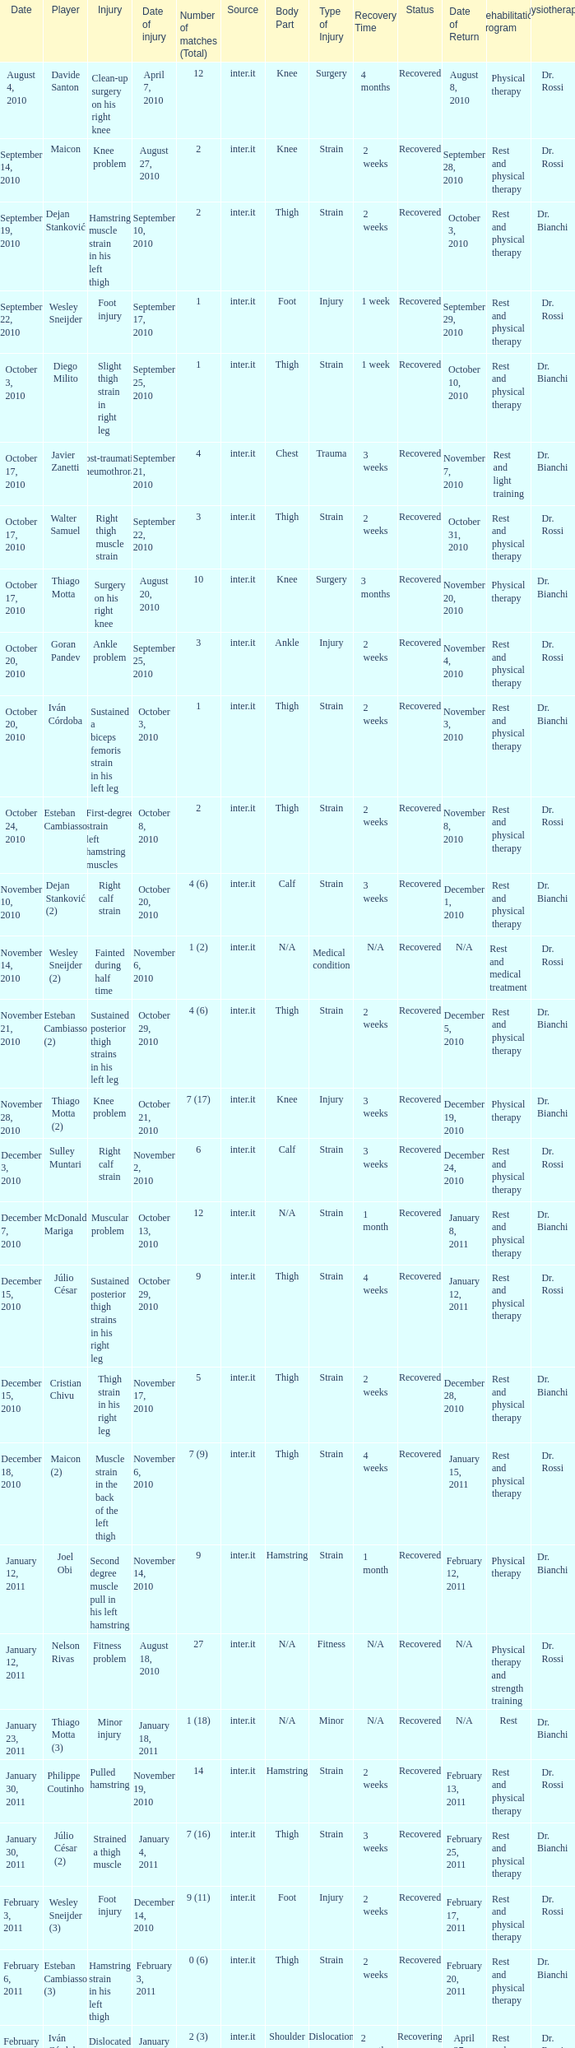What is the date of injury when the injury is foot injury and the number of matches (total) is 1? September 17, 2010. 